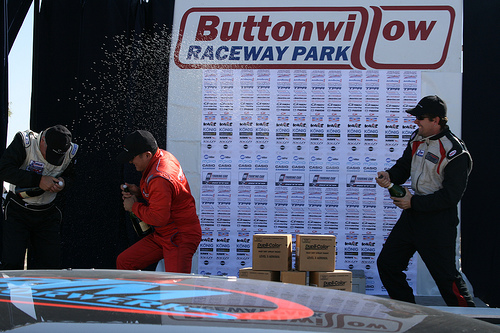<image>
Is there a box on the car? No. The box is not positioned on the car. They may be near each other, but the box is not supported by or resting on top of the car. 